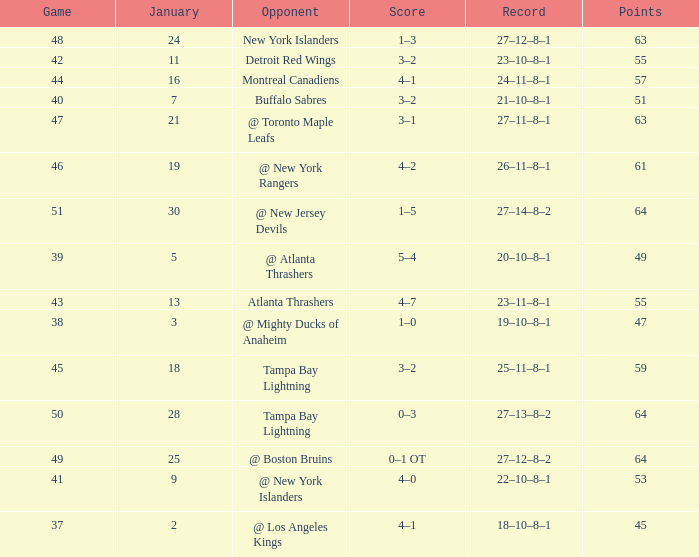Which Points have a Score of 4–1, and a Record of 18–10–8–1, and a January larger than 2? None. 